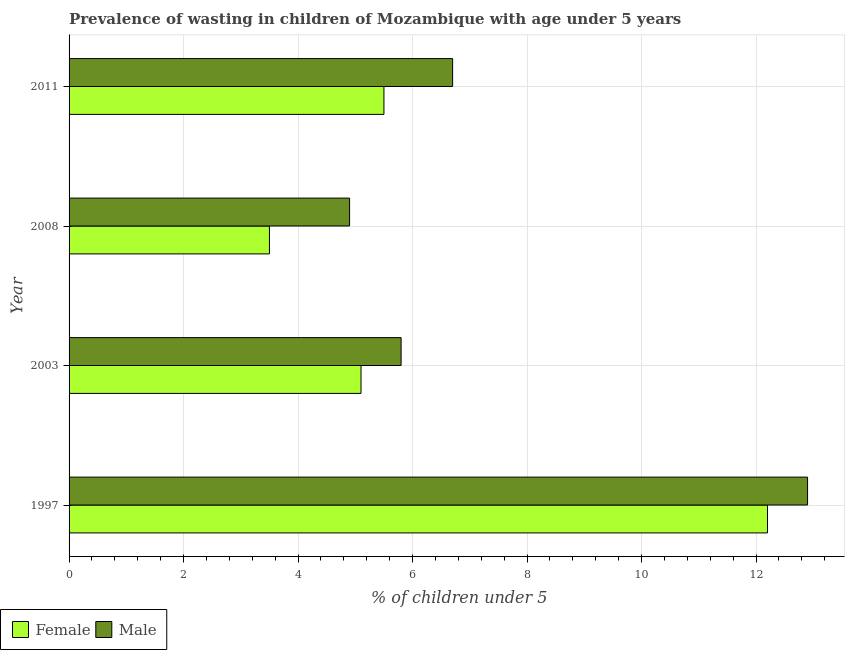Are the number of bars per tick equal to the number of legend labels?
Provide a short and direct response. Yes. Are the number of bars on each tick of the Y-axis equal?
Make the answer very short. Yes. How many bars are there on the 2nd tick from the top?
Your answer should be very brief. 2. How many bars are there on the 2nd tick from the bottom?
Make the answer very short. 2. What is the percentage of undernourished female children in 2008?
Keep it short and to the point. 3.5. Across all years, what is the maximum percentage of undernourished female children?
Keep it short and to the point. 12.2. What is the total percentage of undernourished male children in the graph?
Offer a terse response. 30.3. What is the difference between the percentage of undernourished male children in 1997 and that in 2008?
Ensure brevity in your answer.  8. What is the difference between the percentage of undernourished female children in 2003 and the percentage of undernourished male children in 2011?
Keep it short and to the point. -1.6. What is the average percentage of undernourished male children per year?
Ensure brevity in your answer.  7.58. What is the ratio of the percentage of undernourished female children in 2003 to that in 2011?
Make the answer very short. 0.93. What is the difference between the highest and the second highest percentage of undernourished male children?
Provide a short and direct response. 6.2. In how many years, is the percentage of undernourished female children greater than the average percentage of undernourished female children taken over all years?
Ensure brevity in your answer.  1. What does the 2nd bar from the top in 1997 represents?
Offer a terse response. Female. What does the 2nd bar from the bottom in 2008 represents?
Provide a succinct answer. Male. Are all the bars in the graph horizontal?
Your response must be concise. Yes. How many years are there in the graph?
Ensure brevity in your answer.  4. Does the graph contain any zero values?
Offer a terse response. No. How many legend labels are there?
Your answer should be compact. 2. How are the legend labels stacked?
Your answer should be very brief. Horizontal. What is the title of the graph?
Your response must be concise. Prevalence of wasting in children of Mozambique with age under 5 years. What is the label or title of the X-axis?
Give a very brief answer.  % of children under 5. What is the label or title of the Y-axis?
Give a very brief answer. Year. What is the  % of children under 5 in Female in 1997?
Your answer should be compact. 12.2. What is the  % of children under 5 of Male in 1997?
Provide a short and direct response. 12.9. What is the  % of children under 5 in Female in 2003?
Offer a very short reply. 5.1. What is the  % of children under 5 of Male in 2003?
Your answer should be very brief. 5.8. What is the  % of children under 5 of Male in 2008?
Your answer should be very brief. 4.9. What is the  % of children under 5 in Female in 2011?
Offer a very short reply. 5.5. What is the  % of children under 5 of Male in 2011?
Your response must be concise. 6.7. Across all years, what is the maximum  % of children under 5 in Female?
Keep it short and to the point. 12.2. Across all years, what is the maximum  % of children under 5 in Male?
Your response must be concise. 12.9. Across all years, what is the minimum  % of children under 5 in Female?
Provide a succinct answer. 3.5. Across all years, what is the minimum  % of children under 5 in Male?
Ensure brevity in your answer.  4.9. What is the total  % of children under 5 in Female in the graph?
Offer a very short reply. 26.3. What is the total  % of children under 5 in Male in the graph?
Your answer should be very brief. 30.3. What is the difference between the  % of children under 5 of Female in 1997 and that in 2003?
Your response must be concise. 7.1. What is the difference between the  % of children under 5 in Male in 1997 and that in 2003?
Keep it short and to the point. 7.1. What is the difference between the  % of children under 5 in Male in 1997 and that in 2008?
Provide a short and direct response. 8. What is the difference between the  % of children under 5 in Female in 1997 and that in 2011?
Offer a very short reply. 6.7. What is the difference between the  % of children under 5 of Female in 2003 and that in 2008?
Your answer should be compact. 1.6. What is the difference between the  % of children under 5 of Female in 2003 and that in 2011?
Your answer should be very brief. -0.4. What is the difference between the  % of children under 5 of Male in 2003 and that in 2011?
Make the answer very short. -0.9. What is the difference between the  % of children under 5 of Male in 2008 and that in 2011?
Make the answer very short. -1.8. What is the difference between the  % of children under 5 in Female in 1997 and the  % of children under 5 in Male in 2003?
Keep it short and to the point. 6.4. What is the difference between the  % of children under 5 of Female in 1997 and the  % of children under 5 of Male in 2008?
Provide a succinct answer. 7.3. What is the difference between the  % of children under 5 in Female in 1997 and the  % of children under 5 in Male in 2011?
Your answer should be very brief. 5.5. What is the average  % of children under 5 in Female per year?
Your answer should be compact. 6.58. What is the average  % of children under 5 of Male per year?
Keep it short and to the point. 7.58. In the year 1997, what is the difference between the  % of children under 5 in Female and  % of children under 5 in Male?
Offer a very short reply. -0.7. What is the ratio of the  % of children under 5 in Female in 1997 to that in 2003?
Give a very brief answer. 2.39. What is the ratio of the  % of children under 5 in Male in 1997 to that in 2003?
Give a very brief answer. 2.22. What is the ratio of the  % of children under 5 of Female in 1997 to that in 2008?
Ensure brevity in your answer.  3.49. What is the ratio of the  % of children under 5 in Male in 1997 to that in 2008?
Your answer should be compact. 2.63. What is the ratio of the  % of children under 5 of Female in 1997 to that in 2011?
Your answer should be compact. 2.22. What is the ratio of the  % of children under 5 in Male in 1997 to that in 2011?
Offer a terse response. 1.93. What is the ratio of the  % of children under 5 of Female in 2003 to that in 2008?
Make the answer very short. 1.46. What is the ratio of the  % of children under 5 of Male in 2003 to that in 2008?
Give a very brief answer. 1.18. What is the ratio of the  % of children under 5 of Female in 2003 to that in 2011?
Provide a short and direct response. 0.93. What is the ratio of the  % of children under 5 in Male in 2003 to that in 2011?
Ensure brevity in your answer.  0.87. What is the ratio of the  % of children under 5 in Female in 2008 to that in 2011?
Your answer should be very brief. 0.64. What is the ratio of the  % of children under 5 in Male in 2008 to that in 2011?
Offer a very short reply. 0.73. What is the difference between the highest and the second highest  % of children under 5 in Female?
Give a very brief answer. 6.7. 